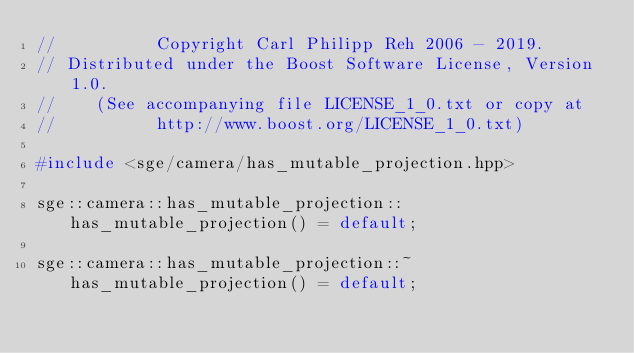Convert code to text. <code><loc_0><loc_0><loc_500><loc_500><_C++_>//          Copyright Carl Philipp Reh 2006 - 2019.
// Distributed under the Boost Software License, Version 1.0.
//    (See accompanying file LICENSE_1_0.txt or copy at
//          http://www.boost.org/LICENSE_1_0.txt)

#include <sge/camera/has_mutable_projection.hpp>

sge::camera::has_mutable_projection::has_mutable_projection() = default;

sge::camera::has_mutable_projection::~has_mutable_projection() = default;
</code> 